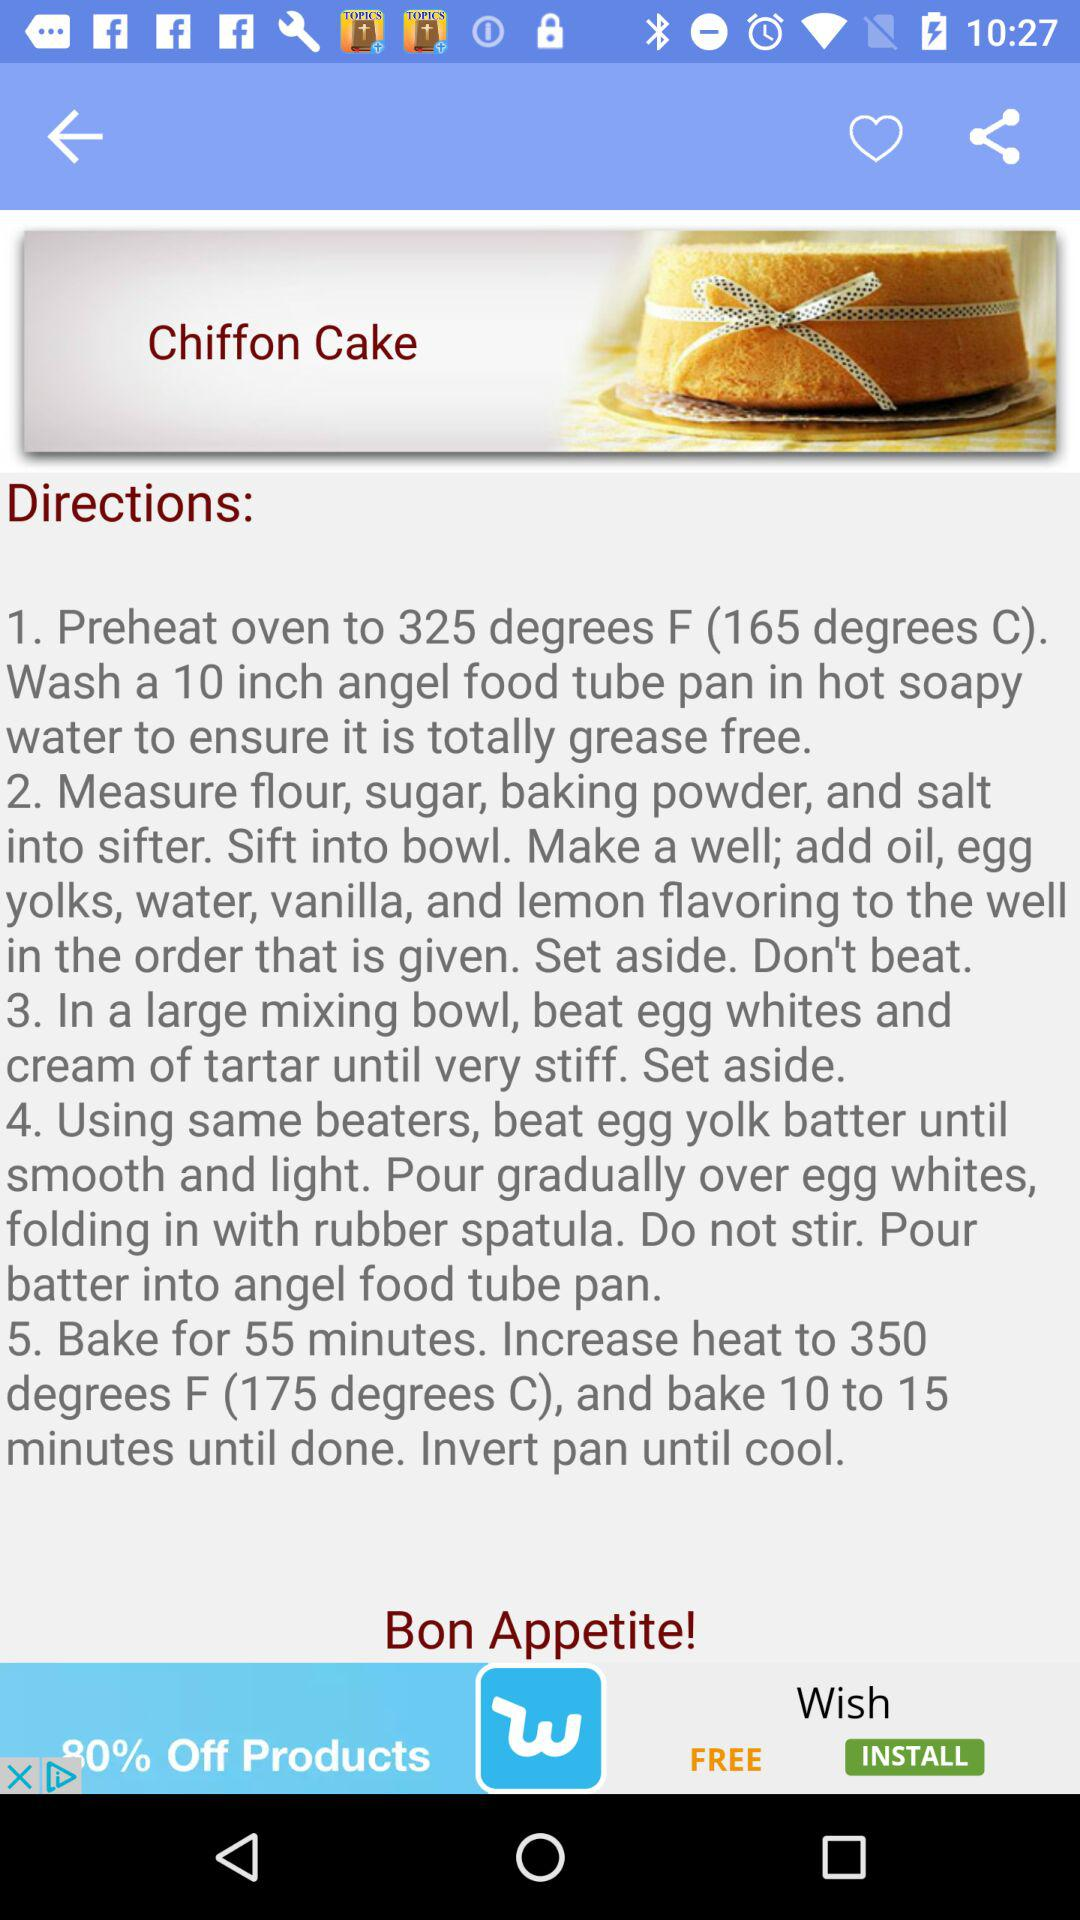How many steps are there in the recipe?
Answer the question using a single word or phrase. 5 